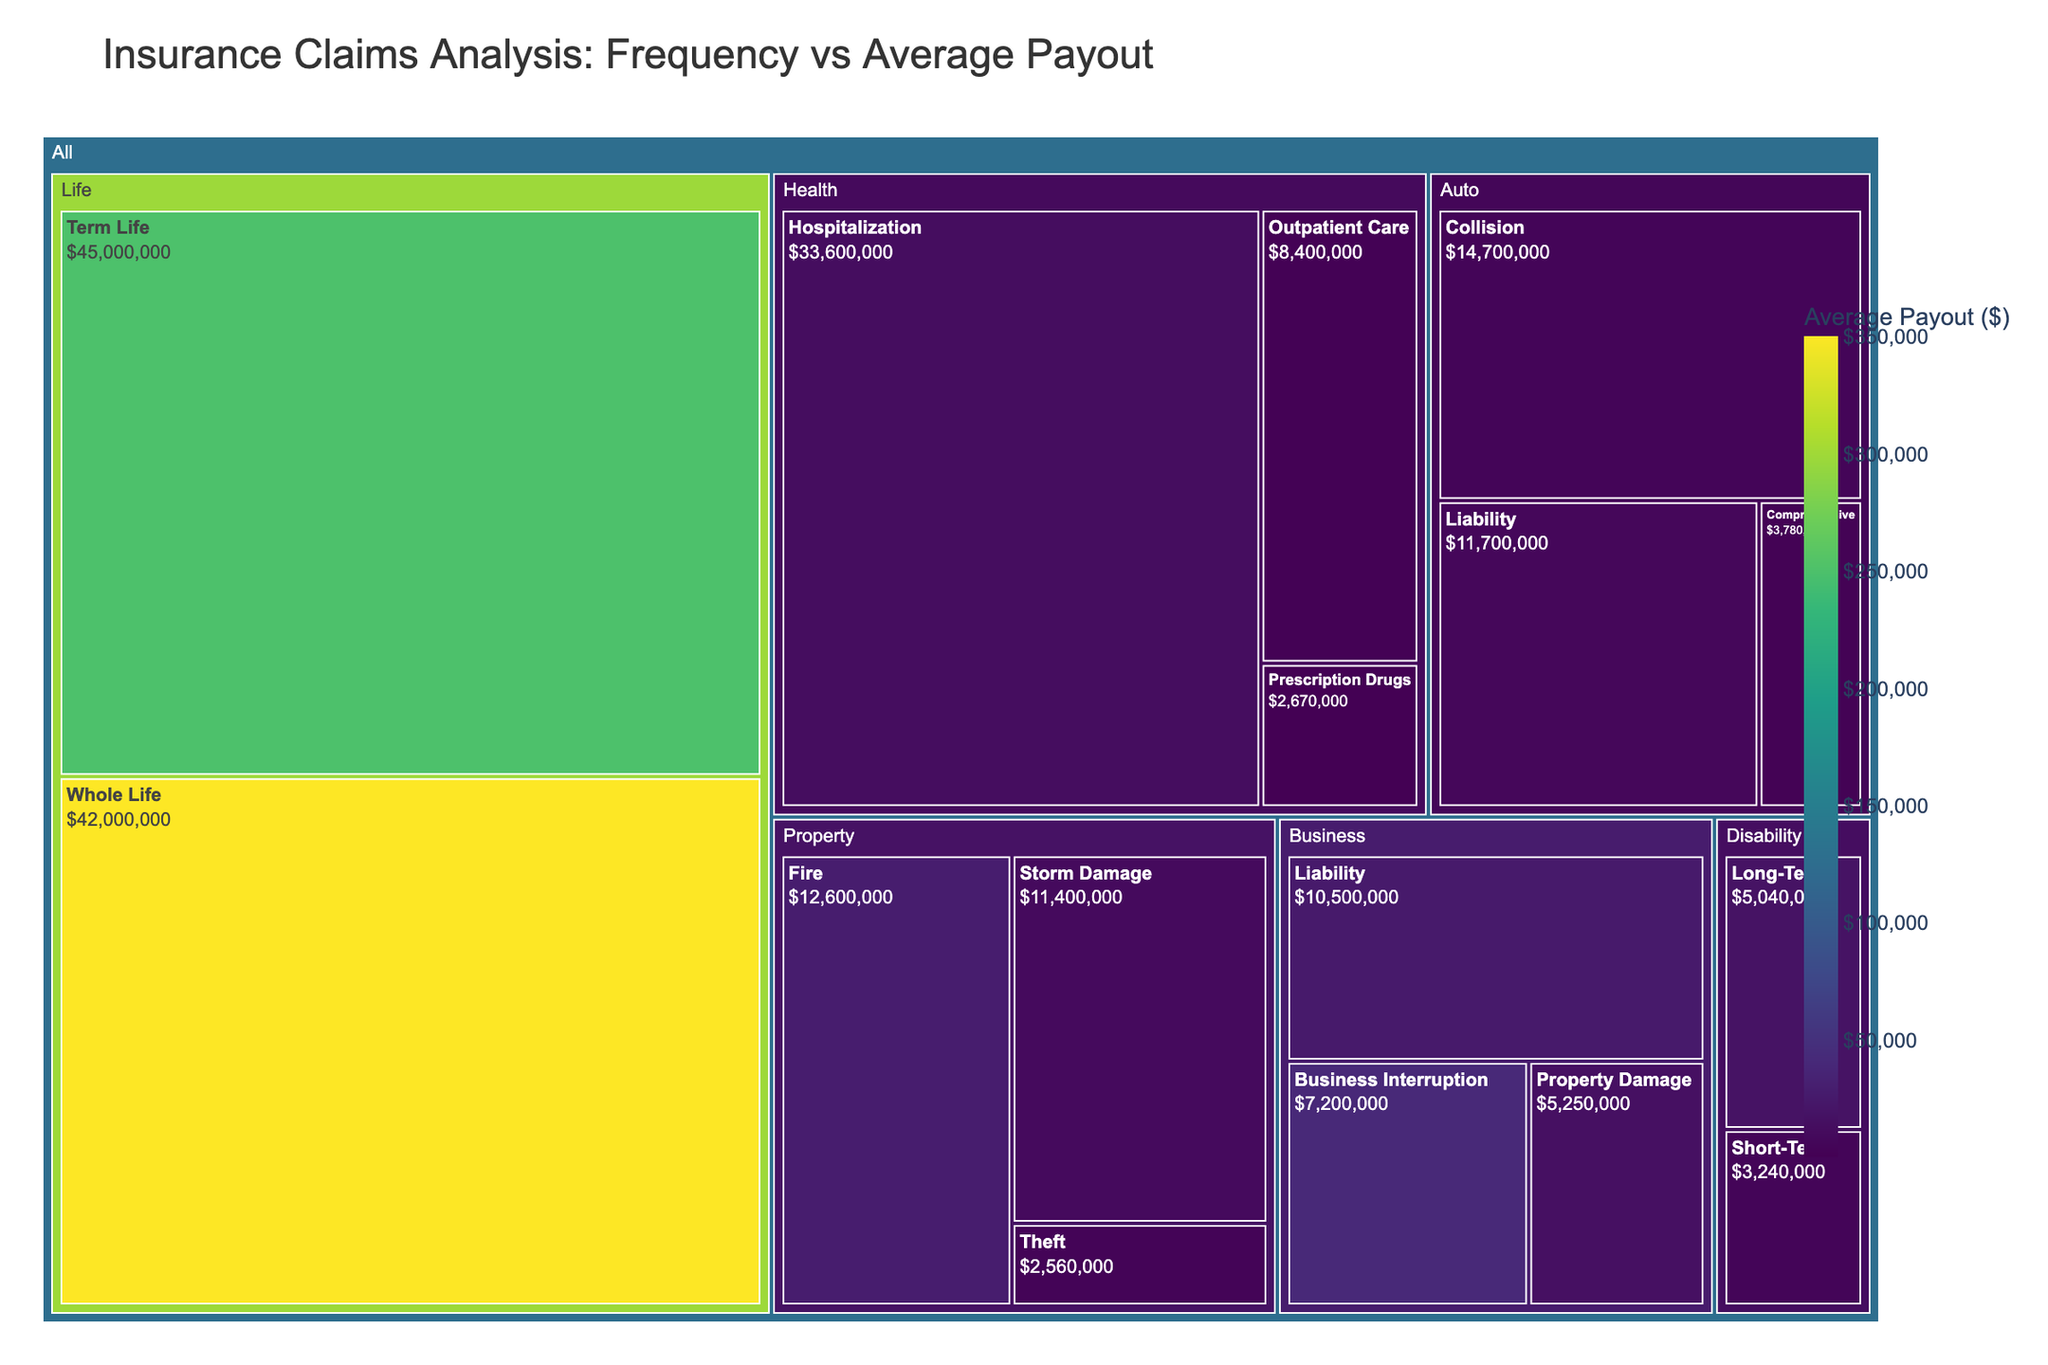What is the title of the treemap? The title of the treemap is displayed at the top and summarizes the focus of the visual analysis.
Answer: Insurance Claims Analysis: Frequency vs Average Payout In which category does the subcategory 'Hospitalization' belong? Each subcategory is nested within its respective category in the hierarchical structure of the treemap. 'Hospitalization' is under the 'Health' category.
Answer: Health Which subcategory has the highest average payout? To identify the subcategory with the highest average payout, look for the text indicating the highest value in the color bar legend. 'Whole Life' has the highest value with an average payout of $350,000.
Answer: Whole Life What is the total number of claims in the 'Auto' category? To find the total number of claims in the 'Auto' category, sum the frequencies of its subcategories: Collision (3500), Comprehensive (2100), and Liability (1800). The total is 3500 + 2100 + 1800 = 7400.
Answer: 7400 Which category has the highest total value of claims? The category with the largest area (representing total value) in the treemap has the highest total value of claims. 'Health' has the highest total value, inferred from its size and values.
Answer: Health Compare the total value of claims between the 'Disability' and 'Life' categories. Which one is higher? Calculate the total value by multiplying frequency and average payout for each subcategory, then sum them: Disability (Short-Term: 720*4500, Long-Term: 280*18000) total = 3,240,000 + 5,040,000 = 8,280,000; Life (Term Life: 180*250000, Whole Life: 120*350000) total = 45,000,000 + 42,000,000 = 87,000,000. Life's total value is higher.
Answer: Life How many subcategories are within the 'Property' category? Count the number of subcategories nested under the 'Property' category. There are three: Fire, Storm Damage, and Theft.
Answer: 3 Which subcategory in the 'Business' category has the lowest frequency? Look for the subcategory with the smallest frequency value in the 'Business' category. 'Business Interruption' has the lowest frequency with 180 claims.
Answer: Business Interruption What is the average payout for subcategories in the 'Health' category? Calculate the average of average payouts for all subcategories within the 'Health' category: (Hospitalization: 12000, Outpatient Care: 1500, Prescription Drugs: 300) average = (12000 + 1500 + 300)/3 = 4,600.
Answer: 4600 Which subcategory in the 'Auto' category has the highest average payout, and what is its value? Identify the subcategory with the highest average payout within the 'Auto' category. 'Liability' has the highest average payout, with a value of $6,500.
Answer: Liability, $6,500 